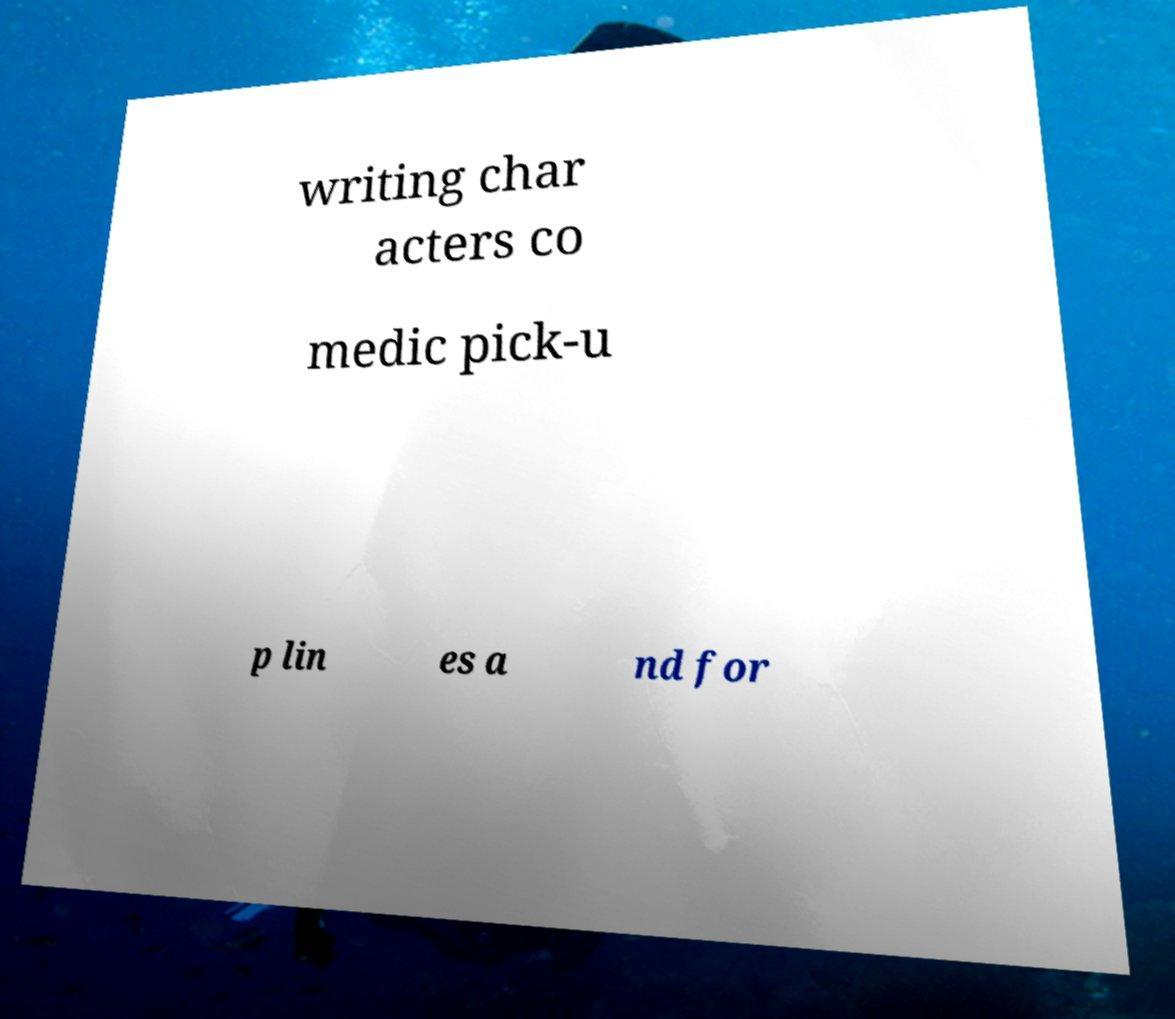Please identify and transcribe the text found in this image. writing char acters co medic pick-u p lin es a nd for 